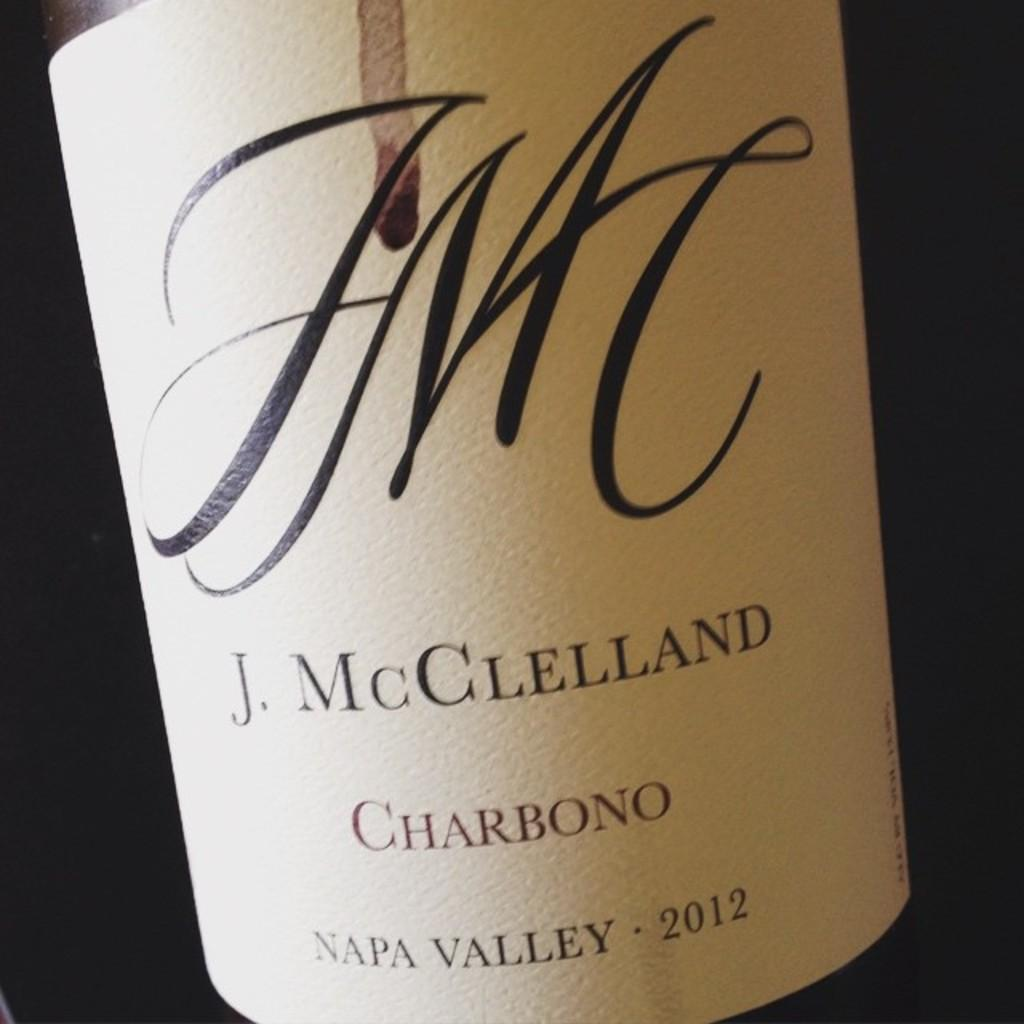<image>
Present a compact description of the photo's key features. A label from a 2012 bottle of Charbono is shown. 